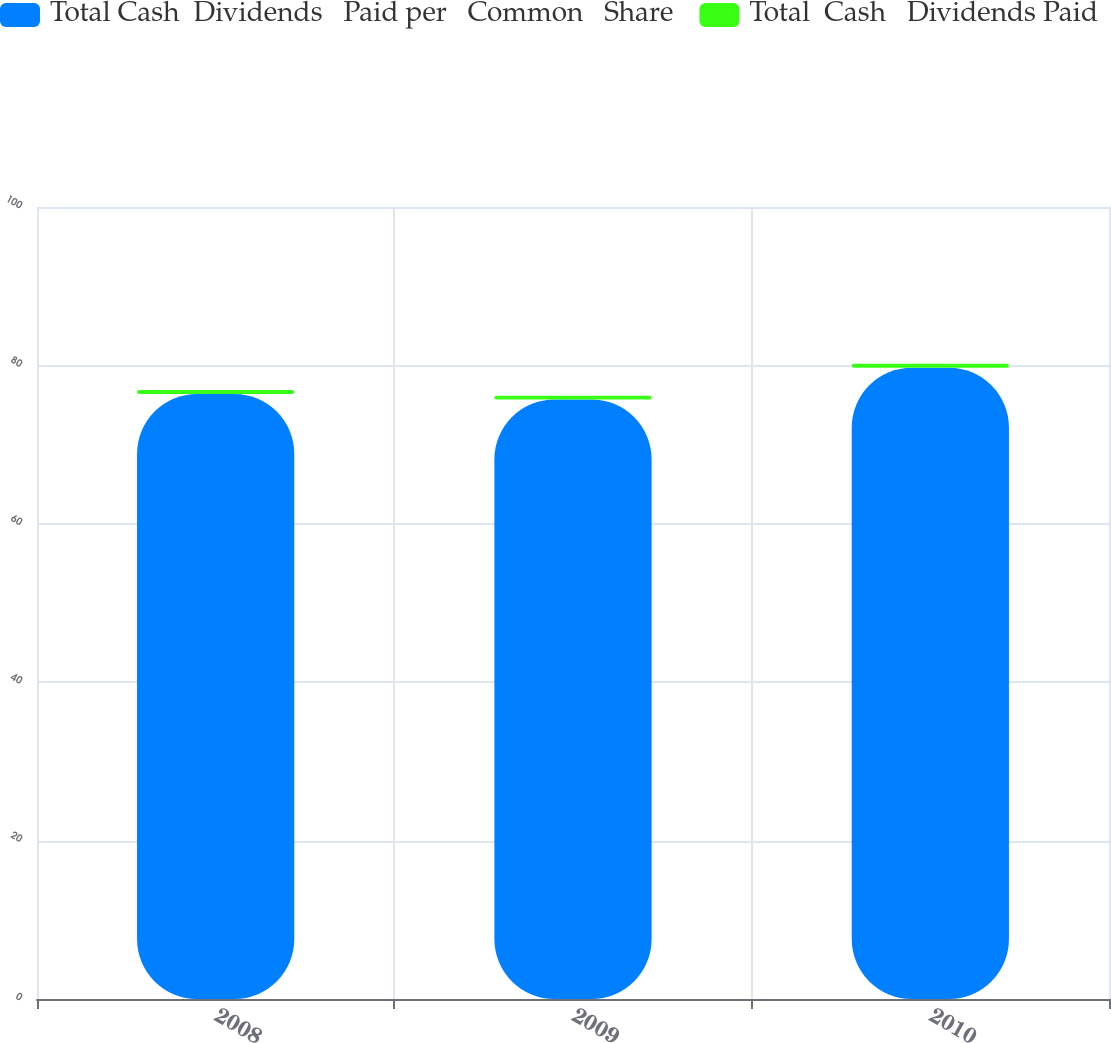Convert chart to OTSL. <chart><loc_0><loc_0><loc_500><loc_500><stacked_bar_chart><ecel><fcel>2008<fcel>2009<fcel>2010<nl><fcel>Total Cash  Dividends   Paid per   Common   Share<fcel>76.4<fcel>75.7<fcel>79.7<nl><fcel>Total  Cash   Dividends Paid<fcel>0.48<fcel>0.48<fcel>0.5<nl></chart> 